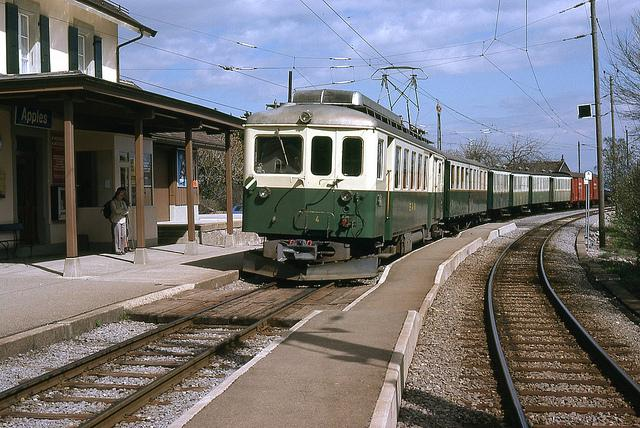What does this train primarily carry?

Choices:
A) steel
B) coal
C) passengers
D) cars passengers 